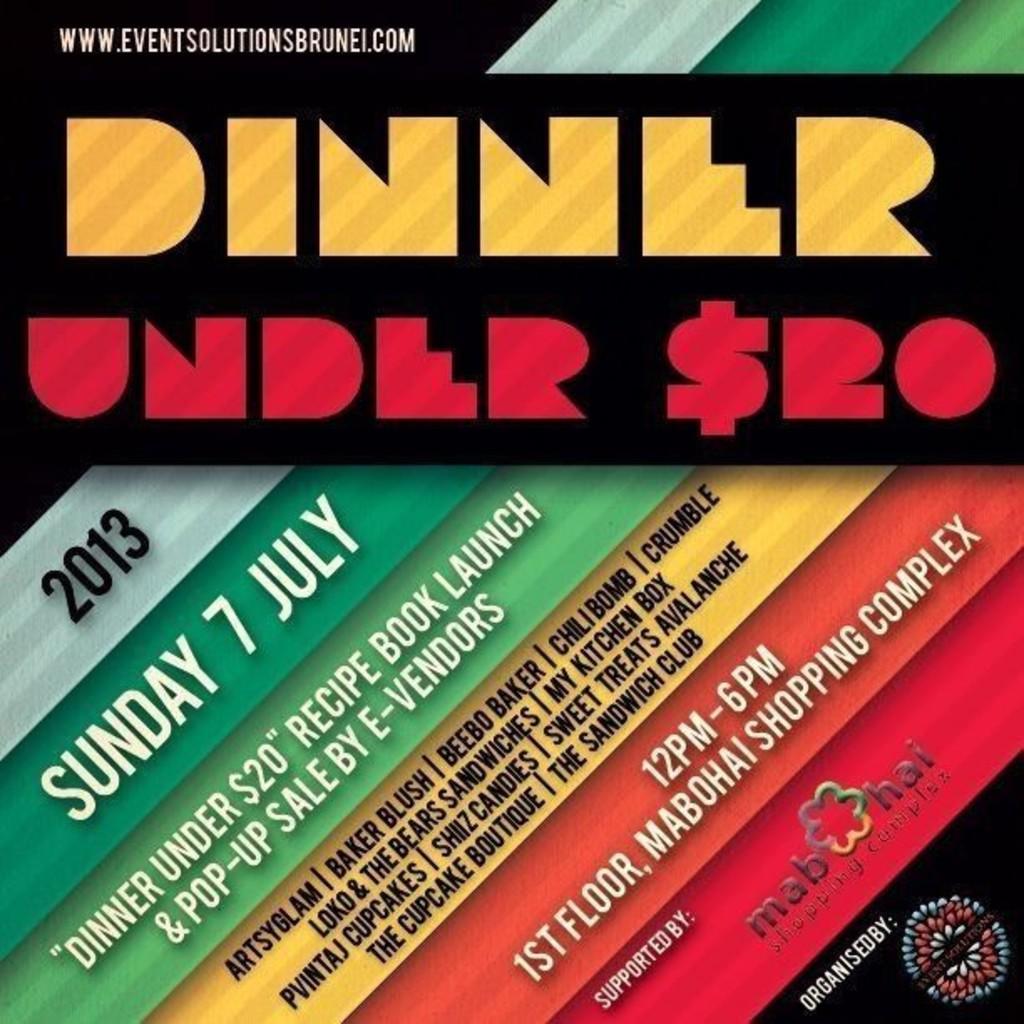Please provide a concise description of this image. In this image there is a advertising poster with some text. 